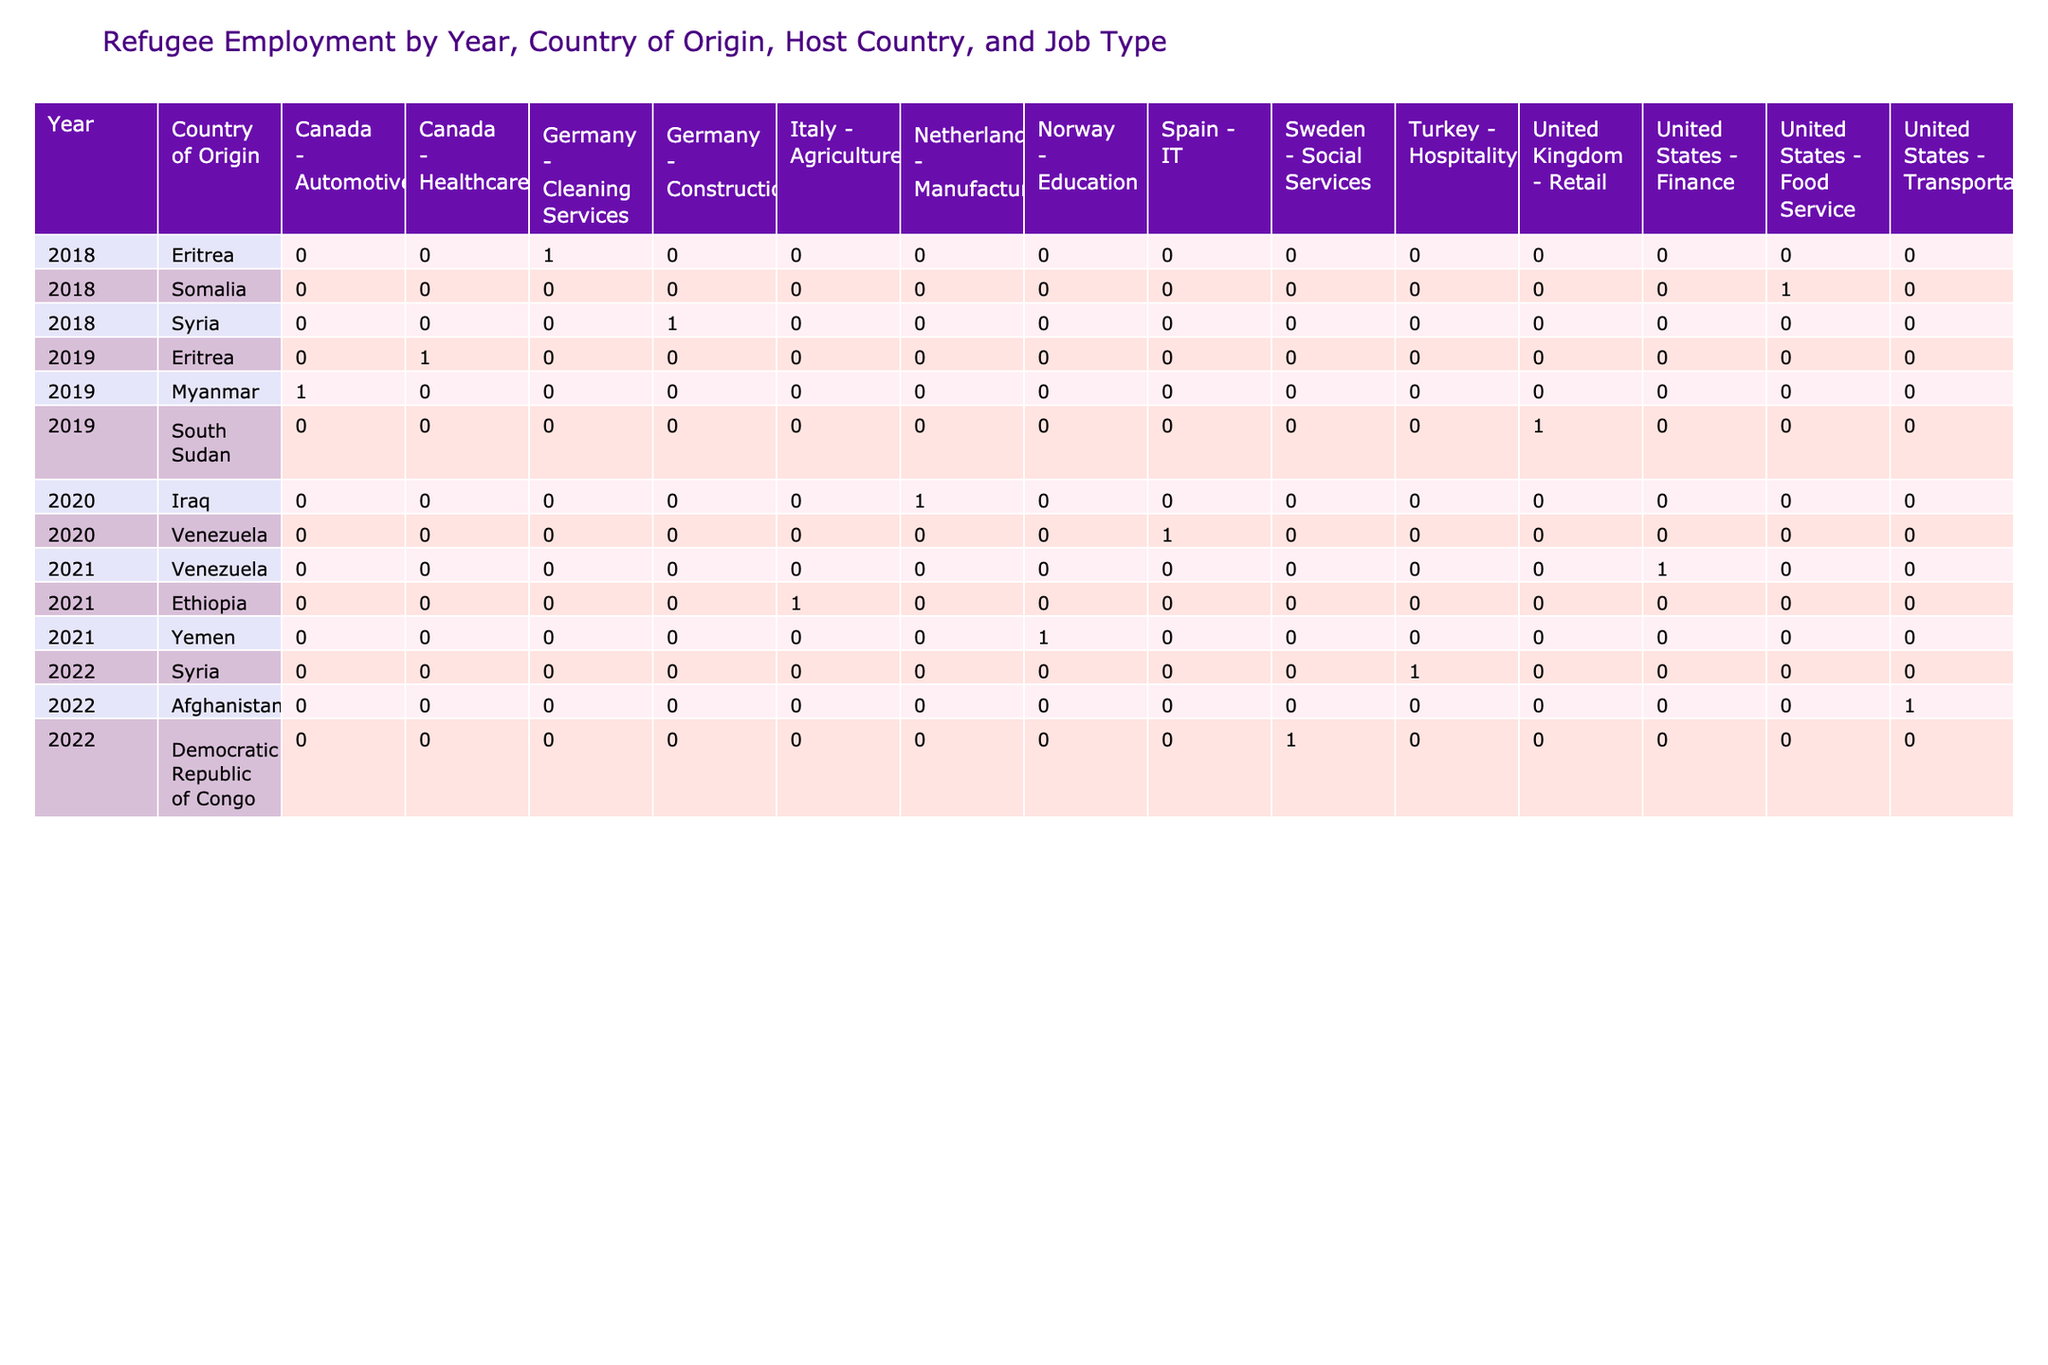What is the job type for employed refugees from Syria in 2018? The table shows that in 2018, an employed refugee from Syria worked in Construction. I can find this information directly in the row corresponding to Syria under the Year 2018, with the Employment Status listed as Employed and the Job Type specified as Construction.
Answer: Construction How many employed refugees from Afghanistan were recorded in 2022? The table indicates that for refugees from Afghanistan in 2022, there is one entry with the employment status "Employed" in the Job Type 'Transportation'. So, counting the entries, there is 1 employed refugee from Afghanistan in that year.
Answer: 1 Did any refugees from the Democratic Republic of Congo have a job in Spain in 2020? Referring to the table, there are no entries for the Democratic Republic of Congo in Spain for the year 2020. Hence, there were no recorded jobs for refugees from that country in Spain for that year.
Answer: No What is the total number of employed refugees from the Eritrea across all years and host countries? To determine the total employed refugees from Eritrea, I need to check all entries where the Country of Origin is Eritrea. Upon reviewing the table, there are two entries (in 2018 with Cleaning Services and in 2019 with Healthcare), both showing Employment Status as Employed. This gives a total of 2 employed refugees from Eritrea.
Answer: 2 In which host country did the most refugees from Somalia find employment in 2019? Evaluating the table, I see that the only entry for Somalia in 2019 is in the United States with the Job Type specified as Food Service. Therefore, since there are no other entries for Somalia in that year, it can be concluded that the most employed refugees from Somalia found jobs in the United States in 2019.
Answer: United States How many more employed refugees were there from Syria compared to Somalia across all years studied? The table indicates that there were 3 employed refugees from Syria (one in 2018, one in 2022, and another entry in 2022) and only one employed refugee from Somalia (in 2018). To find the difference: 3 (Syria) - 1 (Somalia) = 2. Thus, there were 2 more employed refugees from Syria.
Answer: 2 What is the job type of the employed refugees from Venezuela in 2021? The table shows that for the year 2021, employed refugees from Venezuela worked in Finance. I found this directly by looking under the entries for Venezuela and confirming the Job Type for the employed status is Finance.
Answer: Finance 